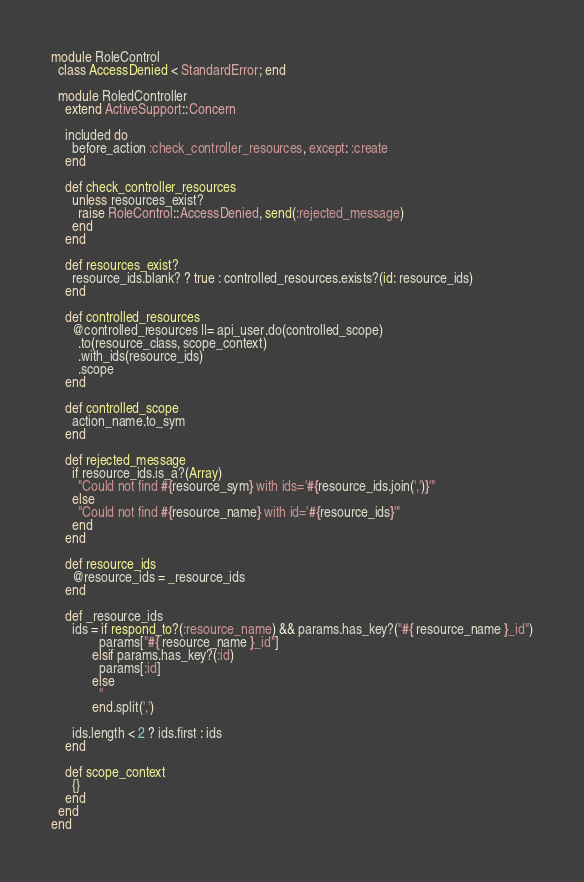Convert code to text. <code><loc_0><loc_0><loc_500><loc_500><_Ruby_>module RoleControl
  class AccessDenied < StandardError; end

  module RoledController
    extend ActiveSupport::Concern

    included do
      before_action :check_controller_resources, except: :create
    end

    def check_controller_resources
      unless resources_exist?
        raise RoleControl::AccessDenied, send(:rejected_message)
      end
    end

    def resources_exist?
      resource_ids.blank? ? true : controlled_resources.exists?(id: resource_ids)
    end

    def controlled_resources
      @controlled_resources ||= api_user.do(controlled_scope)
        .to(resource_class, scope_context)
        .with_ids(resource_ids)
        .scope
    end

    def controlled_scope
      action_name.to_sym
    end

    def rejected_message
      if resource_ids.is_a?(Array)
        "Could not find #{resource_sym} with ids='#{resource_ids.join(',')}'"
      else
        "Could not find #{resource_name} with id='#{resource_ids}'"
      end
    end

    def resource_ids
      @resource_ids = _resource_ids
    end

    def _resource_ids
      ids = if respond_to?(:resource_name) && params.has_key?("#{ resource_name }_id")
              params["#{ resource_name }_id"]
            elsif params.has_key?(:id)
              params[:id]
            else
              ''
            end.split(',')

      ids.length < 2 ? ids.first : ids
    end

    def scope_context
      {}
    end
  end
end
</code> 